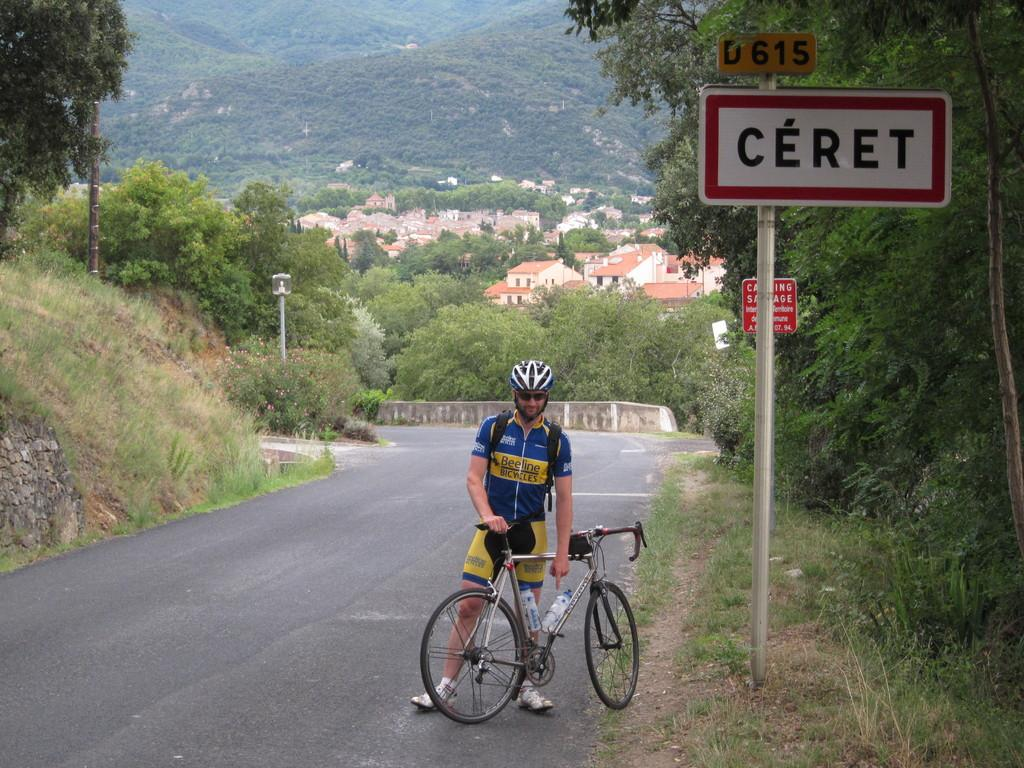What is the main subject of the image? There is a person standing in the middle of the image. What is the person holding in the image? The person is holding a bicycle. What can be seen behind the person in the image? There are trees, poles, buildings, hills, and sign boards visible in the background of the image. How does the person in the image attract the attention of the bats? There are no bats present in the image, so it is not possible to determine how the person might attract their attention. 